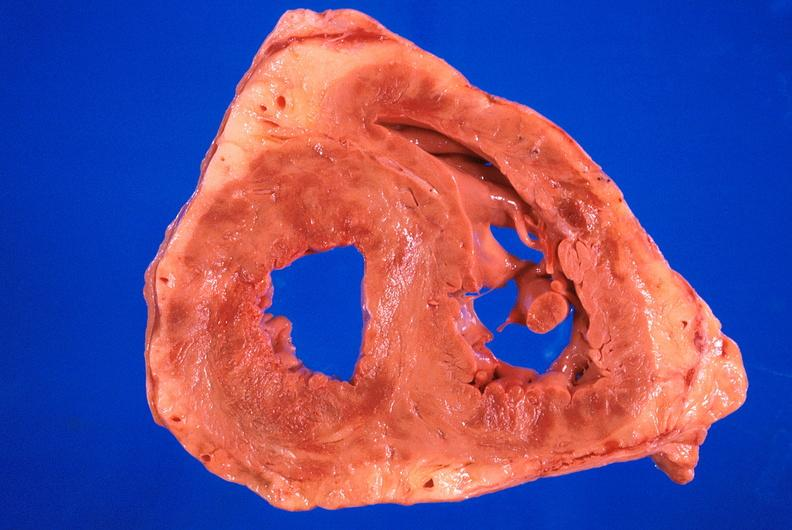what does this image show?
Answer the question using a single word or phrase. Heart 